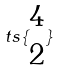Convert formula to latex. <formula><loc_0><loc_0><loc_500><loc_500>t s \{ \begin{matrix} 4 \\ 2 \end{matrix} \}</formula> 